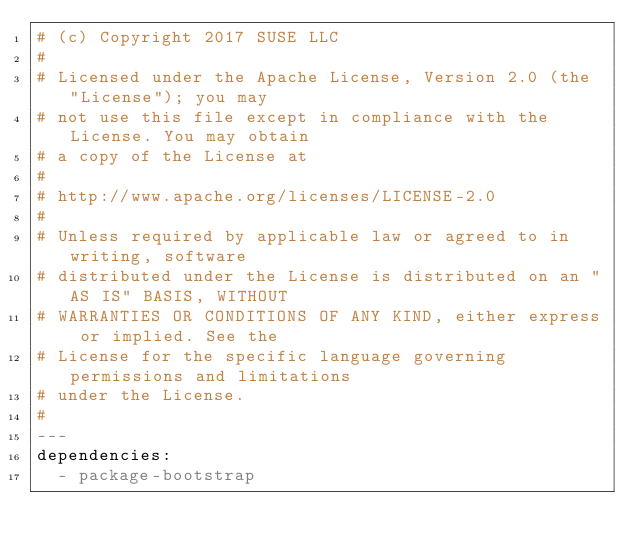<code> <loc_0><loc_0><loc_500><loc_500><_YAML_># (c) Copyright 2017 SUSE LLC
#
# Licensed under the Apache License, Version 2.0 (the "License"); you may
# not use this file except in compliance with the License. You may obtain
# a copy of the License at
#
# http://www.apache.org/licenses/LICENSE-2.0
#
# Unless required by applicable law or agreed to in writing, software
# distributed under the License is distributed on an "AS IS" BASIS, WITHOUT
# WARRANTIES OR CONDITIONS OF ANY KIND, either express or implied. See the
# License for the specific language governing permissions and limitations
# under the License.
#
---
dependencies:
  - package-bootstrap
</code> 